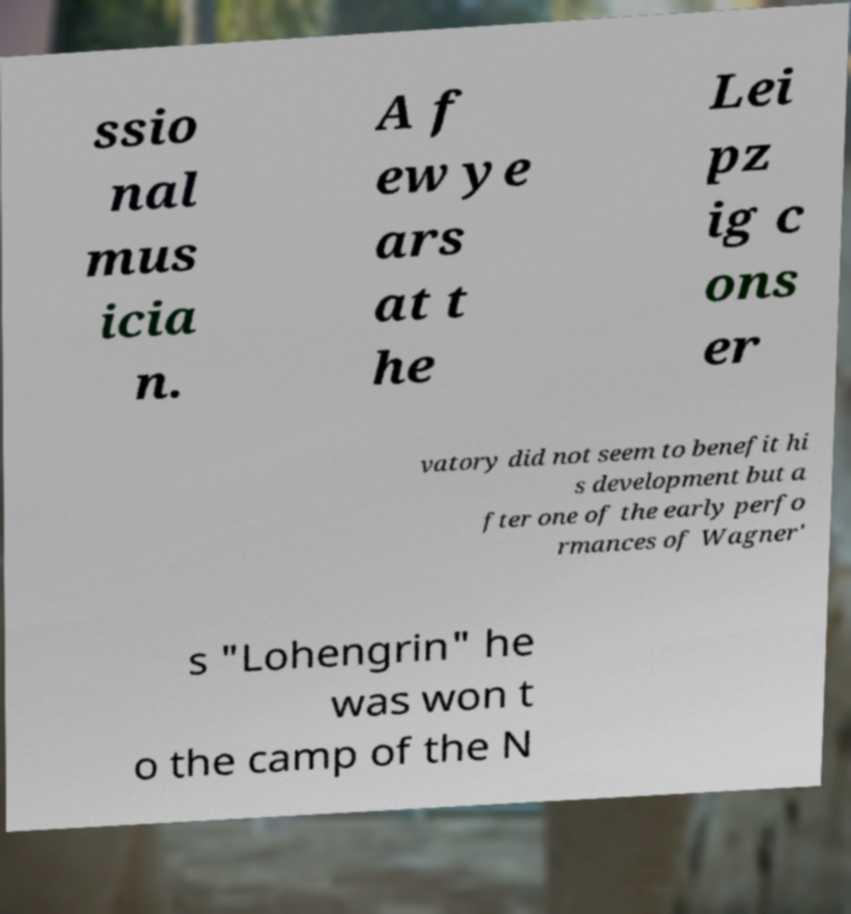Could you assist in decoding the text presented in this image and type it out clearly? ssio nal mus icia n. A f ew ye ars at t he Lei pz ig c ons er vatory did not seem to benefit hi s development but a fter one of the early perfo rmances of Wagner' s "Lohengrin" he was won t o the camp of the N 